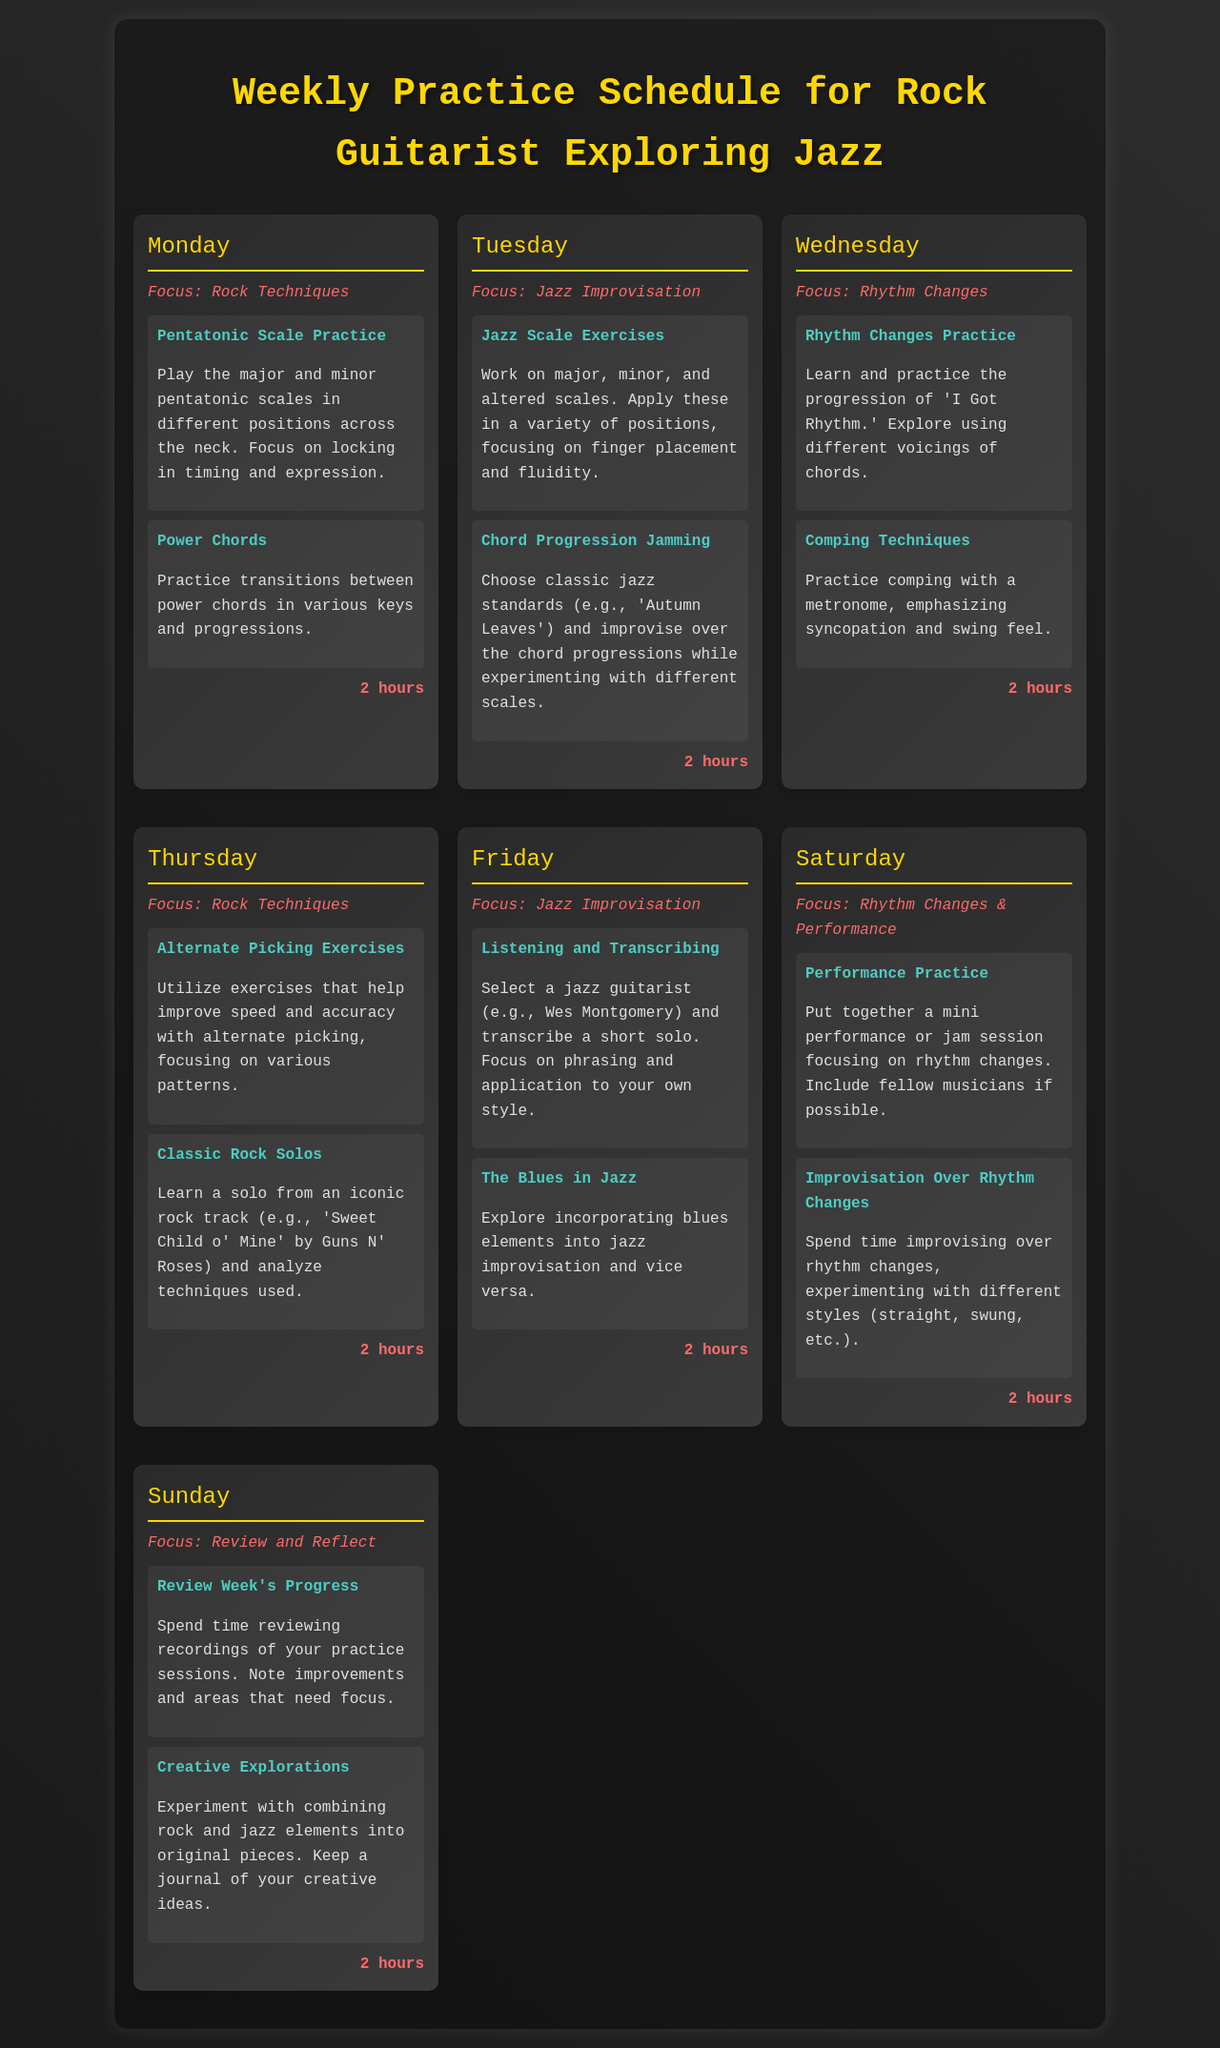What is the focus for Monday? The focus for Monday is Rock Techniques.
Answer: Rock Techniques How many hours are dedicated to each day's practice? Each day has a practice duration of 2 hours.
Answer: 2 hours What scale exercises are practiced on Tuesday? Jazz Scale Exercises involve major, minor, and altered scales.
Answer: Jazz Scale Exercises Which iconic rock track is analyzed on Thursday? The classic rock solo from 'Sweet Child o' Mine' by Guns N' Roses is analyzed.
Answer: Sweet Child o' Mine What should be included in the Saturday practice session? The Saturday practice session includes a mini performance or jam session focusing on rhythm changes.
Answer: Performance Practice What activity is focused on during Sunday’s practice? The focus for Sunday is to Review Week's Progress.
Answer: Review Week's Progress Which jazz guitarist is suggested for transcribing on Friday? Wes Montgomery is the suggested jazz guitarist for transcribing.
Answer: Wes Montgomery What rhythmic feel is emphasized in Wednesday’s comping techniques? Syncopation and swing feel are emphasized in Wednesday’s comping techniques.
Answer: Syncopation and swing feel 